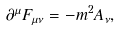<formula> <loc_0><loc_0><loc_500><loc_500>\partial ^ { \mu } F _ { \mu \nu } = - m ^ { 2 } A _ { \nu } ,</formula> 